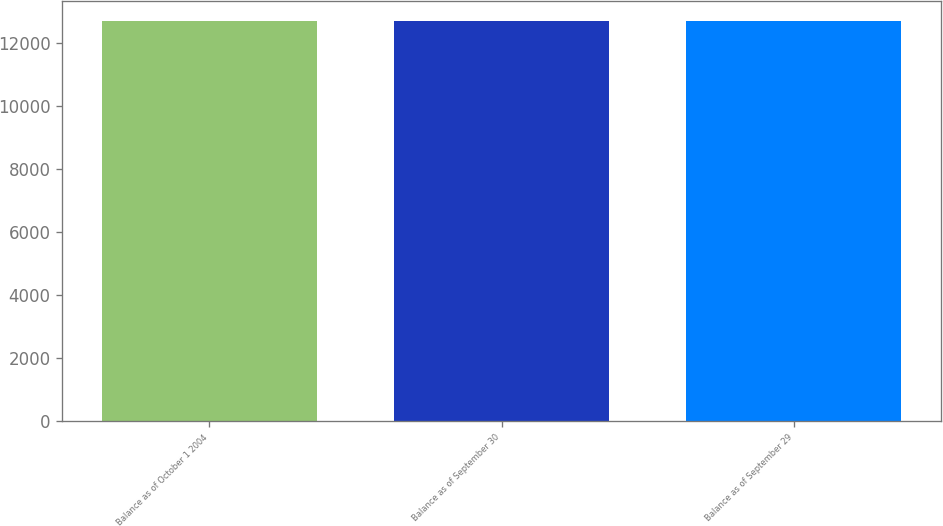Convert chart to OTSL. <chart><loc_0><loc_0><loc_500><loc_500><bar_chart><fcel>Balance as of October 1 2004<fcel>Balance as of September 30<fcel>Balance as of September 29<nl><fcel>12700<fcel>12700.1<fcel>12700.2<nl></chart> 